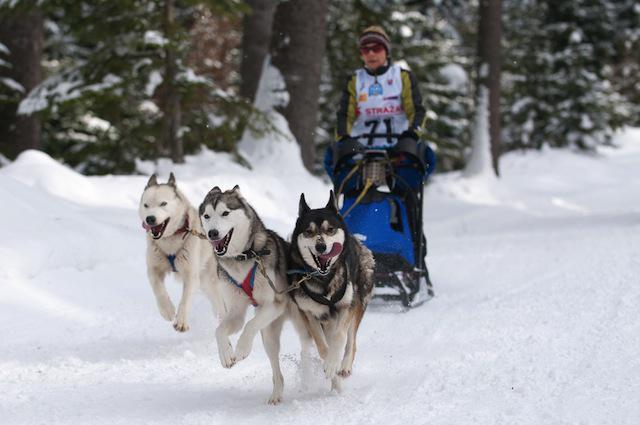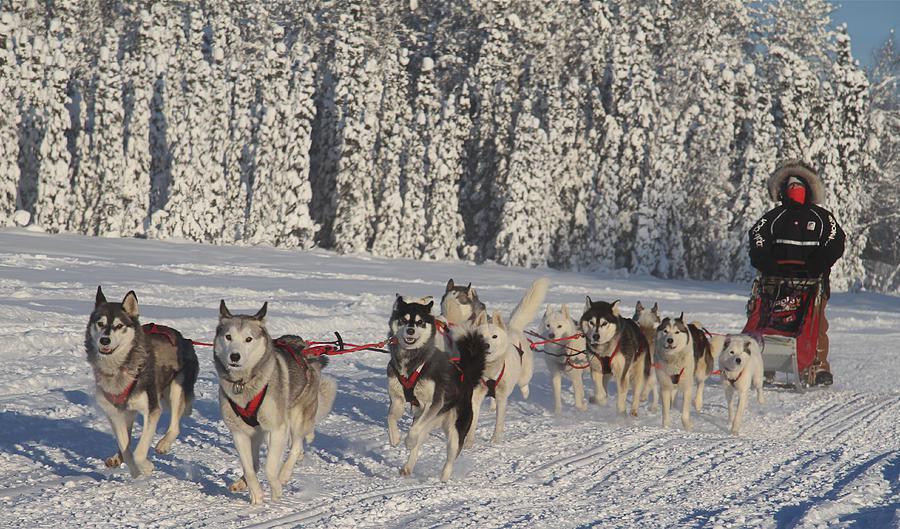The first image is the image on the left, the second image is the image on the right. For the images shown, is this caption "Right image shows a team of harnessed dogs heading leftward, with a line of trees in the background." true? Answer yes or no. Yes. 